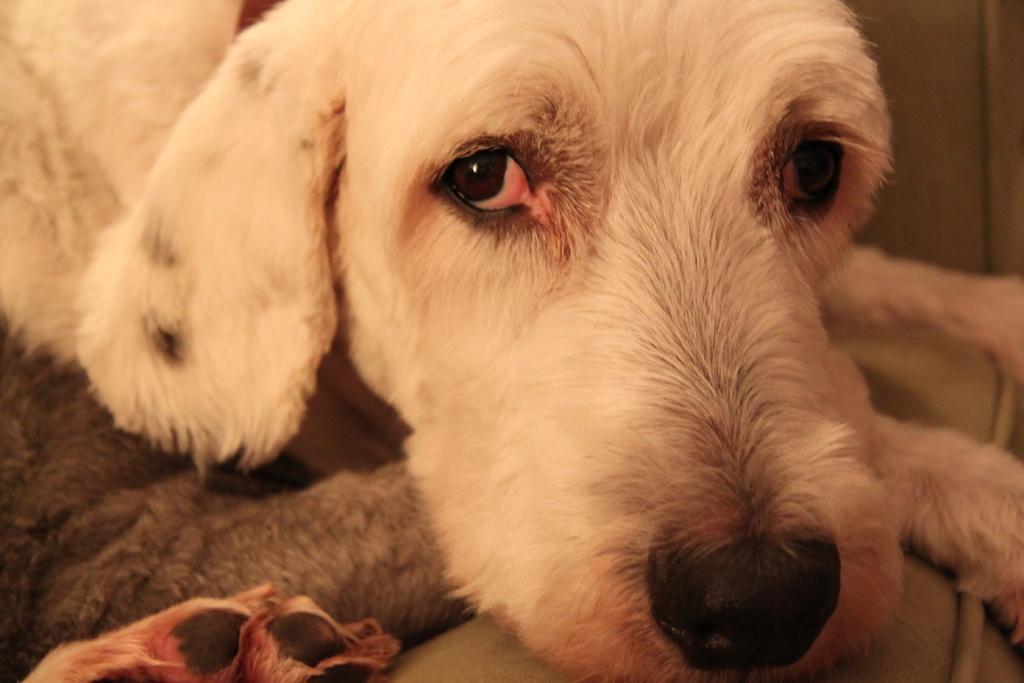In one or two sentences, can you explain what this image depicts? In this image I can see a white colour dog. 